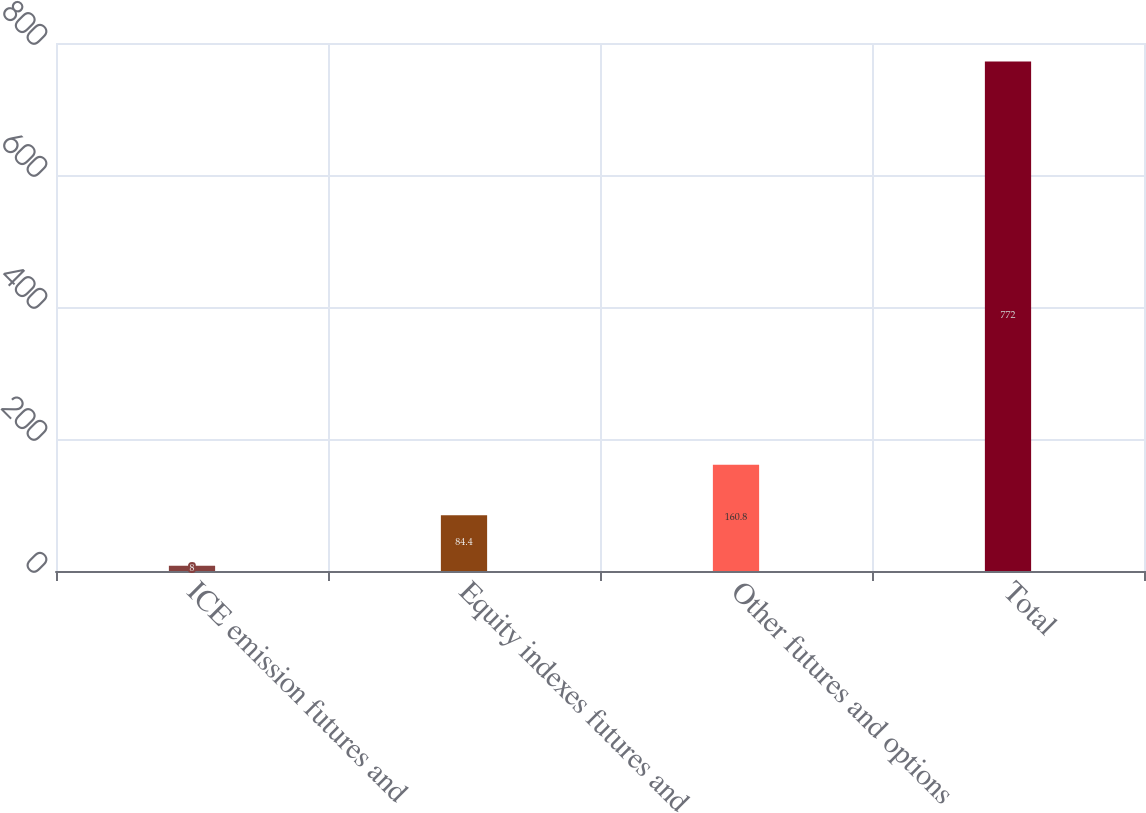Convert chart to OTSL. <chart><loc_0><loc_0><loc_500><loc_500><bar_chart><fcel>ICE emission futures and<fcel>Equity indexes futures and<fcel>Other futures and options<fcel>Total<nl><fcel>8<fcel>84.4<fcel>160.8<fcel>772<nl></chart> 